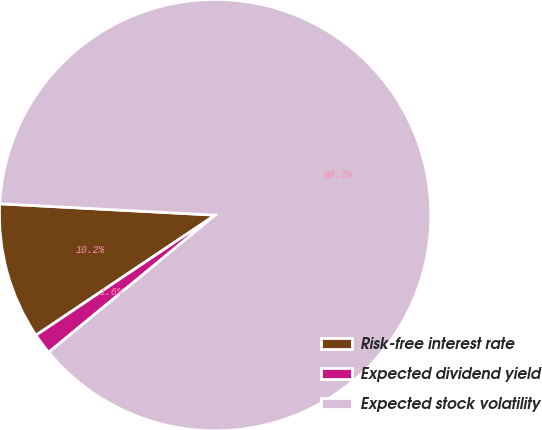Convert chart. <chart><loc_0><loc_0><loc_500><loc_500><pie_chart><fcel>Risk-free interest rate<fcel>Expected dividend yield<fcel>Expected stock volatility<nl><fcel>10.24%<fcel>1.57%<fcel>88.19%<nl></chart> 